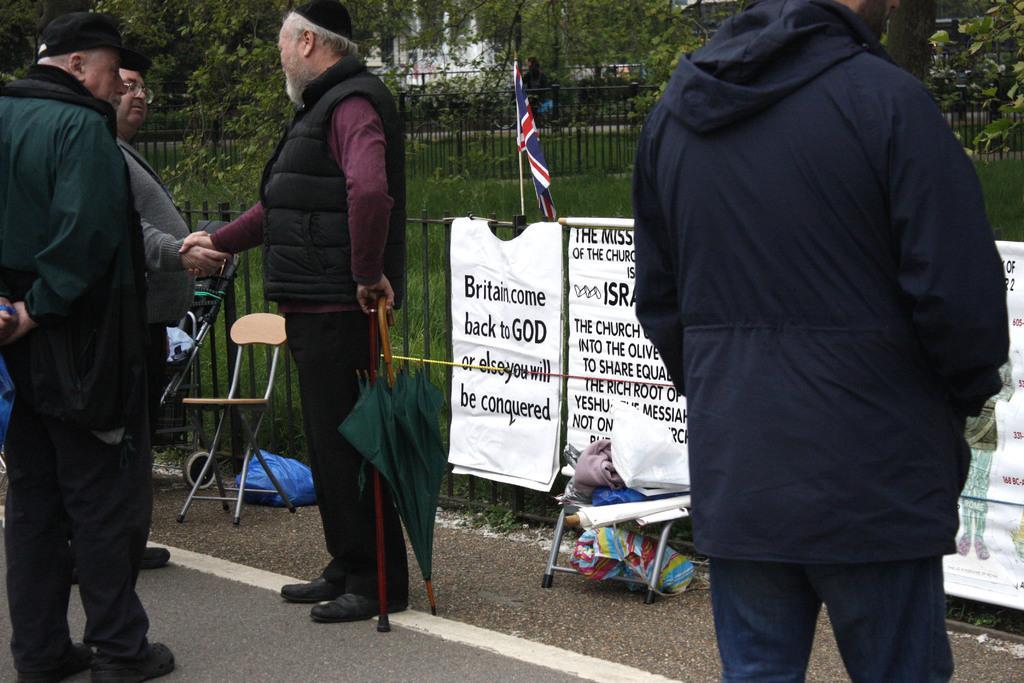Please provide a concise description of this image. This picture is clicked outside. On the left we can see the group of persons standing on the ground. On the right there is a person seems to be walking on the ground and we can see a green color umbrella and we can see the chair and many other objects are placed on the ground. In the background we can see the banners on which we can see the text and we can see the flag, metal fence, grass, plants, trees and buildings. 